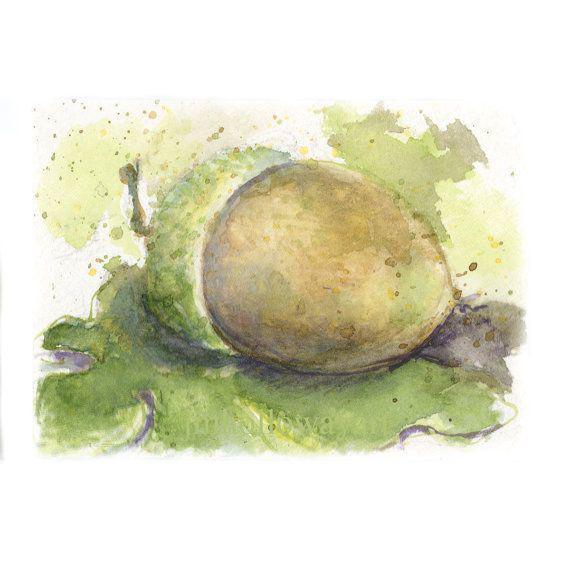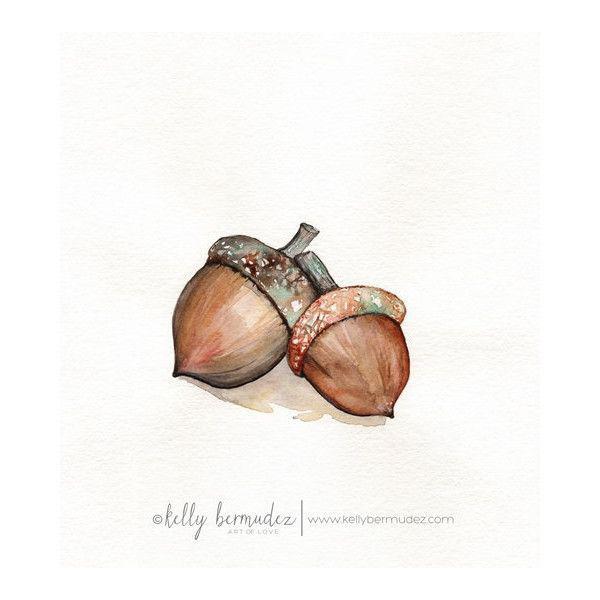The first image is the image on the left, the second image is the image on the right. Examine the images to the left and right. Is the description "The left image includes two brown acorns, and at least one oak leaf on a stem above them." accurate? Answer yes or no. No. The first image is the image on the left, the second image is the image on the right. Considering the images on both sides, is "There are exactly two acorns in the left image." valid? Answer yes or no. No. 